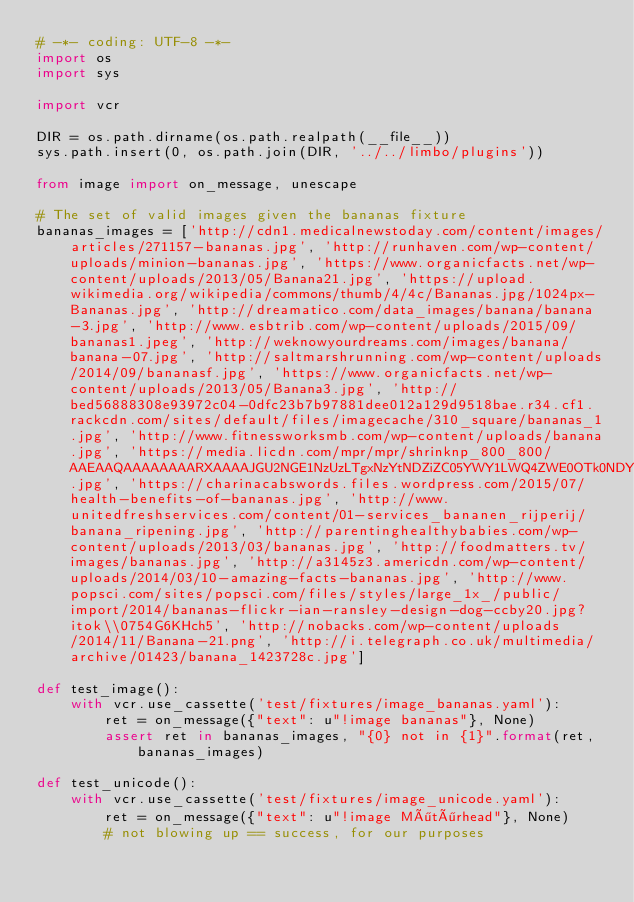Convert code to text. <code><loc_0><loc_0><loc_500><loc_500><_Python_># -*- coding: UTF-8 -*-
import os
import sys

import vcr

DIR = os.path.dirname(os.path.realpath(__file__))
sys.path.insert(0, os.path.join(DIR, '../../limbo/plugins'))

from image import on_message, unescape

# The set of valid images given the bananas fixture
bananas_images = ['http://cdn1.medicalnewstoday.com/content/images/articles/271157-bananas.jpg', 'http://runhaven.com/wp-content/uploads/minion-bananas.jpg', 'https://www.organicfacts.net/wp-content/uploads/2013/05/Banana21.jpg', 'https://upload.wikimedia.org/wikipedia/commons/thumb/4/4c/Bananas.jpg/1024px-Bananas.jpg', 'http://dreamatico.com/data_images/banana/banana-3.jpg', 'http://www.esbtrib.com/wp-content/uploads/2015/09/bananas1.jpeg', 'http://weknowyourdreams.com/images/banana/banana-07.jpg', 'http://saltmarshrunning.com/wp-content/uploads/2014/09/bananasf.jpg', 'https://www.organicfacts.net/wp-content/uploads/2013/05/Banana3.jpg', 'http://bed56888308e93972c04-0dfc23b7b97881dee012a129d9518bae.r34.cf1.rackcdn.com/sites/default/files/imagecache/310_square/bananas_1.jpg', 'http://www.fitnessworksmb.com/wp-content/uploads/banana.jpg', 'https://media.licdn.com/mpr/mpr/shrinknp_800_800/AAEAAQAAAAAAAARXAAAAJGU2NGE1NzUzLTgxNzYtNDZiZC05YWY1LWQ4ZWE0OTk0NDY2Mw.jpg', 'https://charinacabswords.files.wordpress.com/2015/07/health-benefits-of-bananas.jpg', 'http://www.unitedfreshservices.com/content/01-services_bananen_rijperij/banana_ripening.jpg', 'http://parentinghealthybabies.com/wp-content/uploads/2013/03/bananas.jpg', 'http://foodmatters.tv/images/bananas.jpg', 'http://a3145z3.americdn.com/wp-content/uploads/2014/03/10-amazing-facts-bananas.jpg', 'http://www.popsci.com/sites/popsci.com/files/styles/large_1x_/public/import/2014/bananas-flickr-ian-ransley-design-dog-ccby20.jpg?itok\\0754G6KHch5', 'http://nobacks.com/wp-content/uploads/2014/11/Banana-21.png', 'http://i.telegraph.co.uk/multimedia/archive/01423/banana_1423728c.jpg']

def test_image():
    with vcr.use_cassette('test/fixtures/image_bananas.yaml'):
        ret = on_message({"text": u"!image bananas"}, None)
        assert ret in bananas_images, "{0} not in {1}".format(ret, bananas_images)

def test_unicode():
    with vcr.use_cassette('test/fixtures/image_unicode.yaml'):
        ret = on_message({"text": u"!image Mötörhead"}, None)
        # not blowing up == success, for our purposes
</code> 